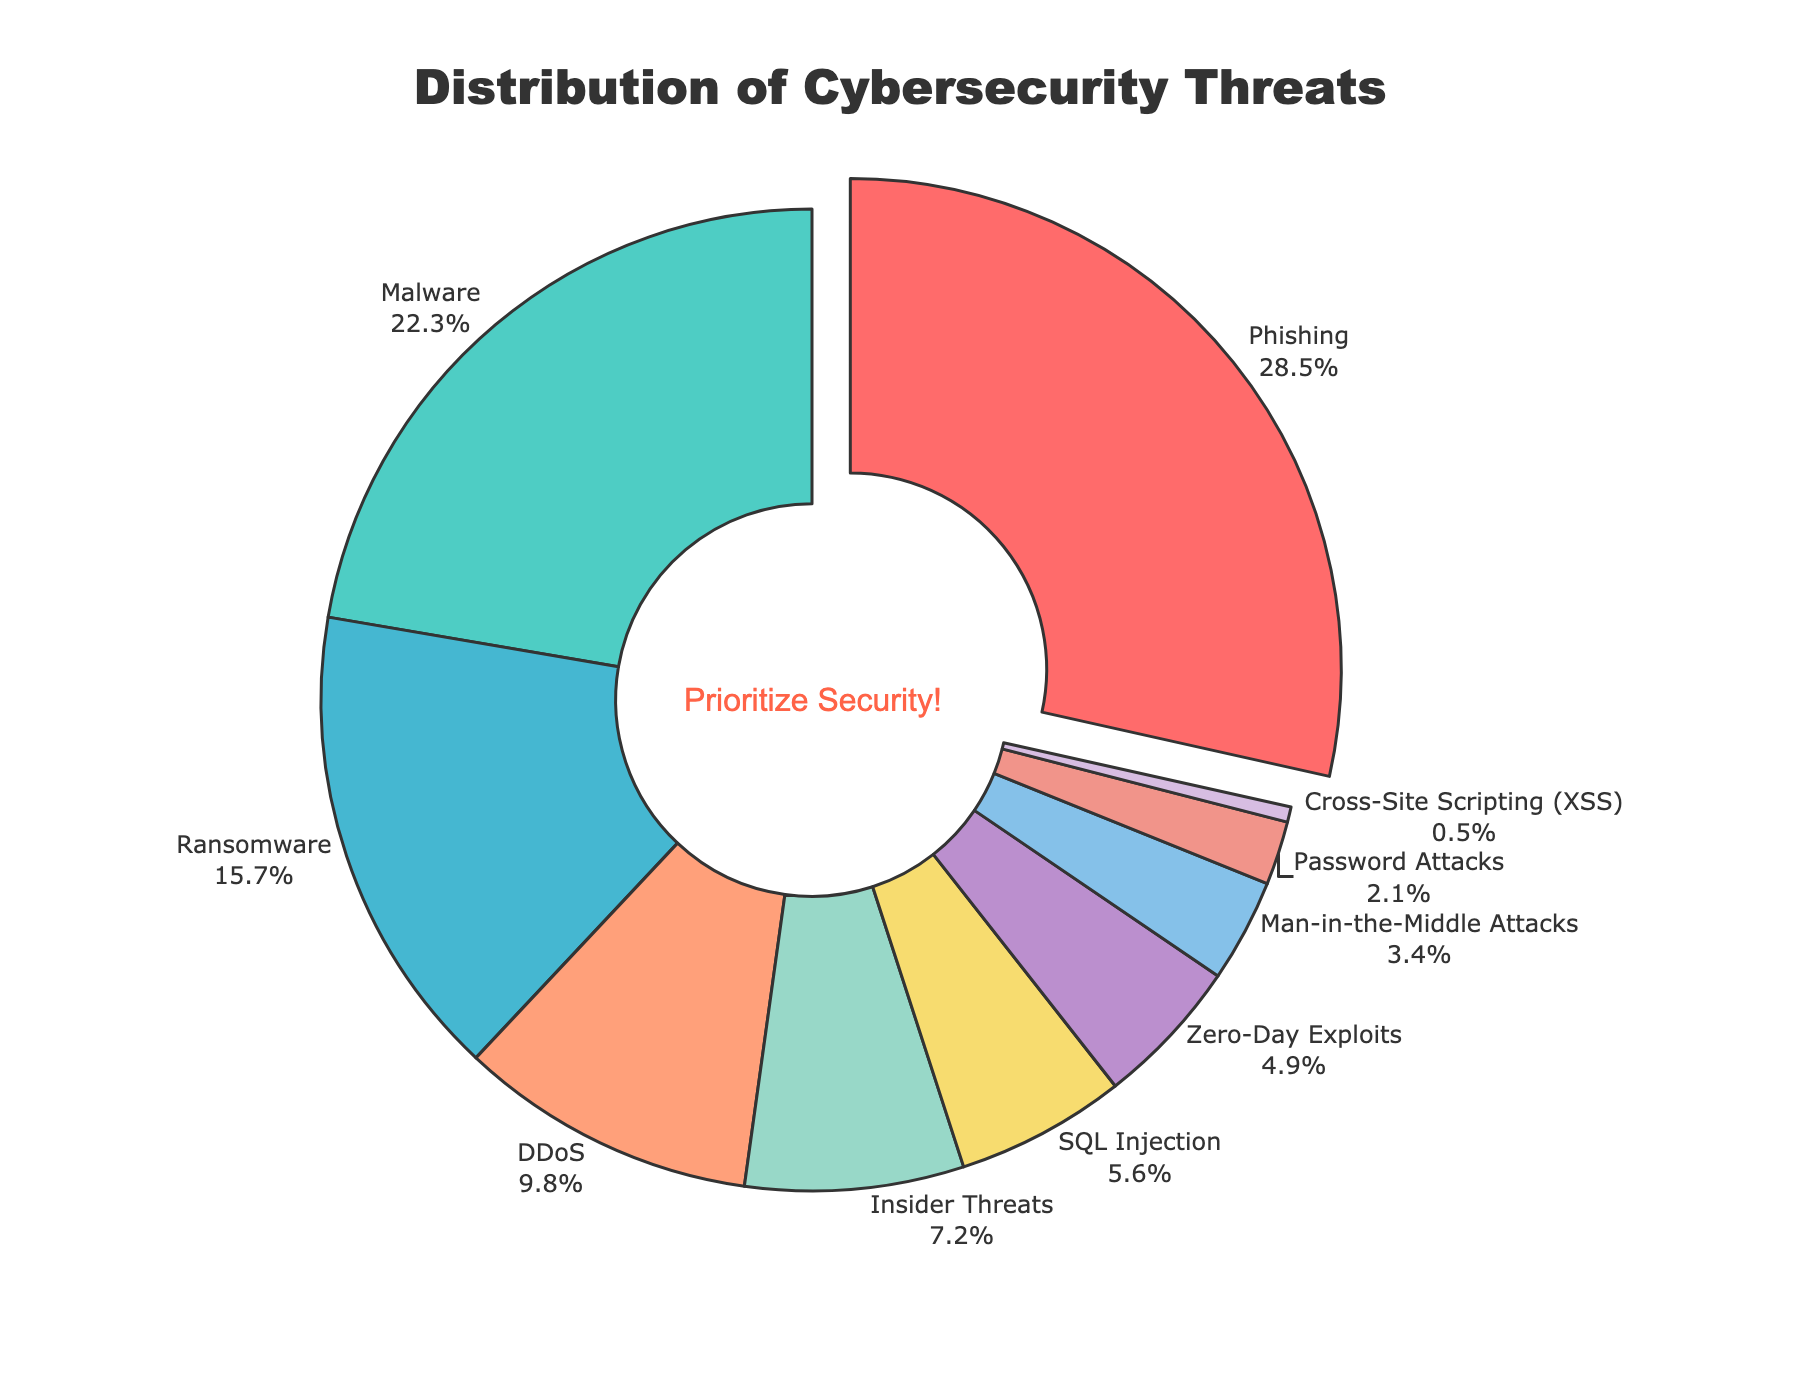What's the most common cybersecurity threat? The pie chart shows that 'Phishing' is the most dominant slice, which means it's the most common cybersecurity threat.
Answer: Phishing What's the least common cybersecurity threat? The smallest slice in the pie chart is labeled 'Cross-Site Scripting (XSS)', making it the least common threat.
Answer: Cross-Site Scripting (XSS) What percentage of threats does Malware and Zero-Day Exploits combined account for? Add the percentages of Malware (22.3%) and Zero-Day Exploits (4.9%). So, 22.3 + 4.9 = 27.2%.
Answer: 27.2% Which threat has a proportion just above Insider Threats? By looking at the chart, the slice just larger than 'Insider Threats' (7.2%) is 'DDoS' with 9.8%.
Answer: DDoS What visual feature distinguishes the most common threat in the pie chart? The largest slice for 'Phishing' is slightly pulled out from the center of the pie, making it stand out.
Answer: Pulled out How do Ransomware and DDoS compare in terms of prevalence? Ransomware accounts for 15.7% while DDoS accounts for 9.8%, meaning Ransomware is more prevalent.
Answer: Ransomware is more prevalent Which two threat types together make up roughly one-third of the total threats? Adding Phishing (28.5%) and Man-in-the-Middle Attacks (3.4%), we get 28.5 + 3.4 = 31.9%, which is roughly one-third of the total threats.
Answer: Phishing and Man-in-the-Middle Attacks What is the combined percentage of threats labeled under SQL Injection, Zero-Day Exploits, and Password Attacks? Summing the percentages for SQL Injection (5.6%), Zero-Day Exploits (4.9%), and Password Attacks (2.1%) gives 5.6 + 4.9 + 2.1 = 12.6%.
Answer: 12.6% Excluding the largest threat, what is the average percentage of the remaining threats? First, exclude Phishing (28.5%), then sum the remaining percentages: 22.3 + 15.7 + 9.8 + 7.2 + 5.6 + 4.9 + 3.4 + 2.1 + 0.5 = 71.5. Divide by the 9 remaining threats: 71.5 / 9 ≈ 7.94%.
Answer: 7.94% 